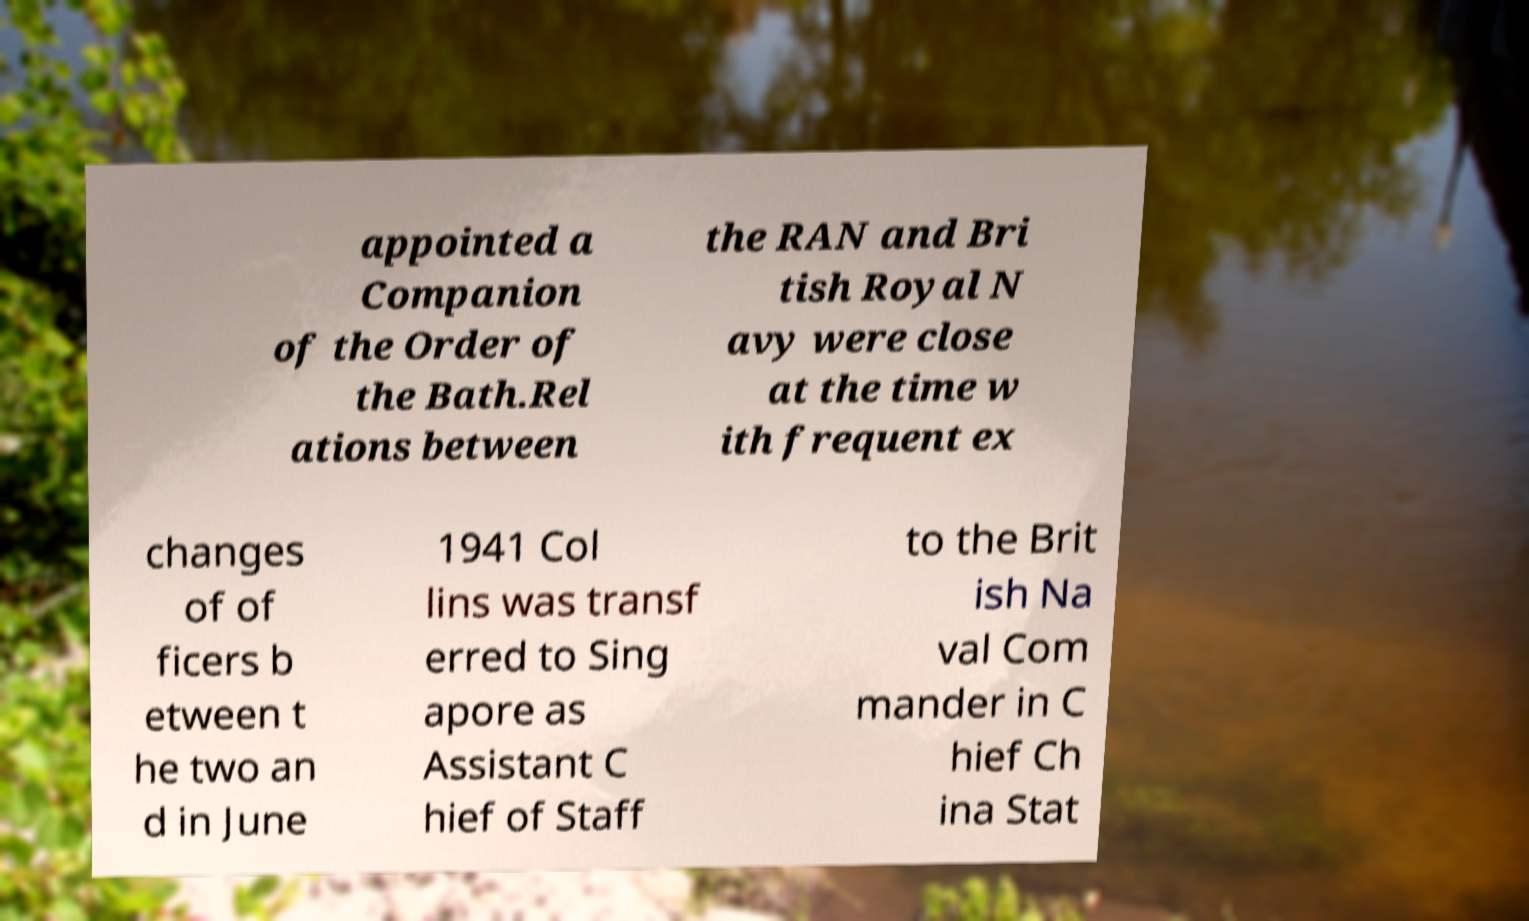Please identify and transcribe the text found in this image. appointed a Companion of the Order of the Bath.Rel ations between the RAN and Bri tish Royal N avy were close at the time w ith frequent ex changes of of ficers b etween t he two an d in June 1941 Col lins was transf erred to Sing apore as Assistant C hief of Staff to the Brit ish Na val Com mander in C hief Ch ina Stat 